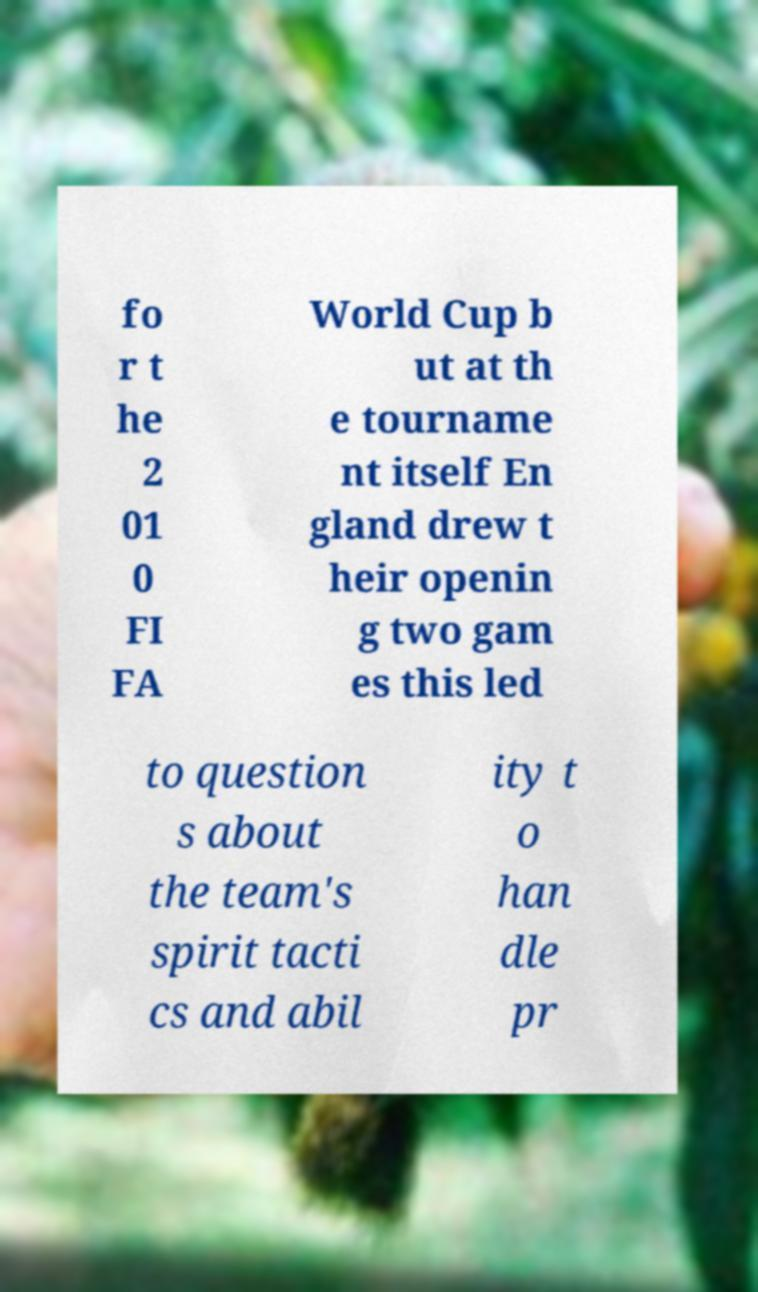I need the written content from this picture converted into text. Can you do that? fo r t he 2 01 0 FI FA World Cup b ut at th e tourname nt itself En gland drew t heir openin g two gam es this led to question s about the team's spirit tacti cs and abil ity t o han dle pr 